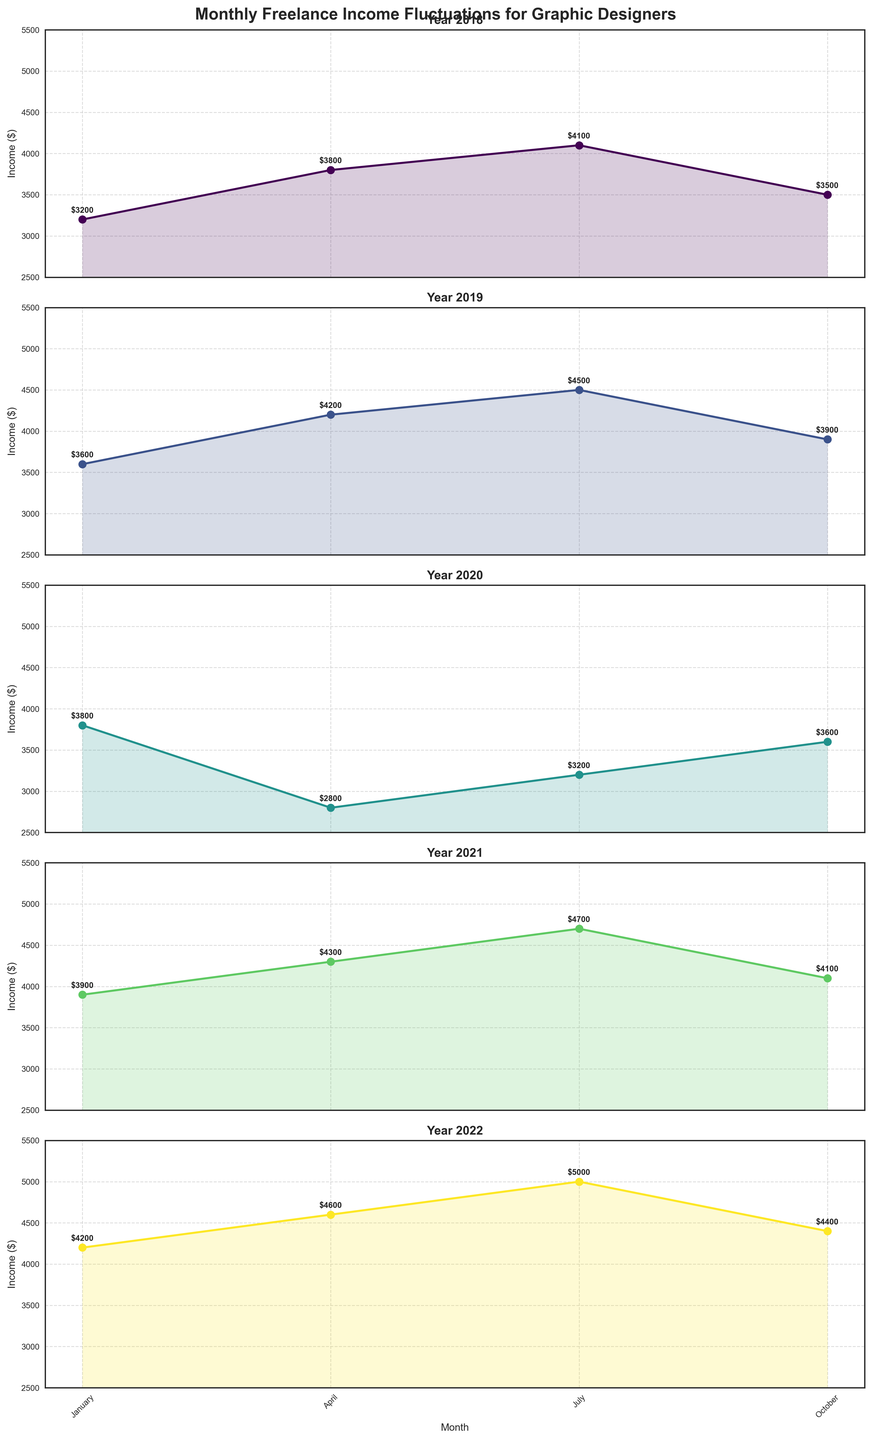What's the average income for the year 2022? Look at the 2022 subplot and sum up the income for all months: ($4200 + $4600 + $5000 + $4400) = $18200. Now, divide by 4 (number of months): $18200 / 4 = $4550
Answer: $4550 Which month had the lowest income in the entire timeline? Identify the lowest data point in all subplots. From visual inspection, the lowest value appears in April 2020 with an income of $2800
Answer: April 2020 What is the difference between the highest income value and the lowest income value across the entire period? Find the highest and lowest values in all subplots: highest ($5000 in July 2022) and lowest ($2800 in April 2020). Difference: $5000 - $2800 = $2200
Answer: $2200 How does the income in October 2020 compare to the income in January 2021? Look at the specific data points in respective subplots: October 2020 ($3600) and January 2021 ($3900). October 2020's income is $300 less than January 2021
Answer: October 2020 is $300 less than January 2021 What is the overall trend pattern observed over the 5-year period? Assessing all subplots, there is an initial rise in years 2018 and 2019, a drop in 2020, followed by a steep rise in subsequent years 2021 and 2022, indicating a recovery and growth trend.
Answer: Recovery and growth trend 